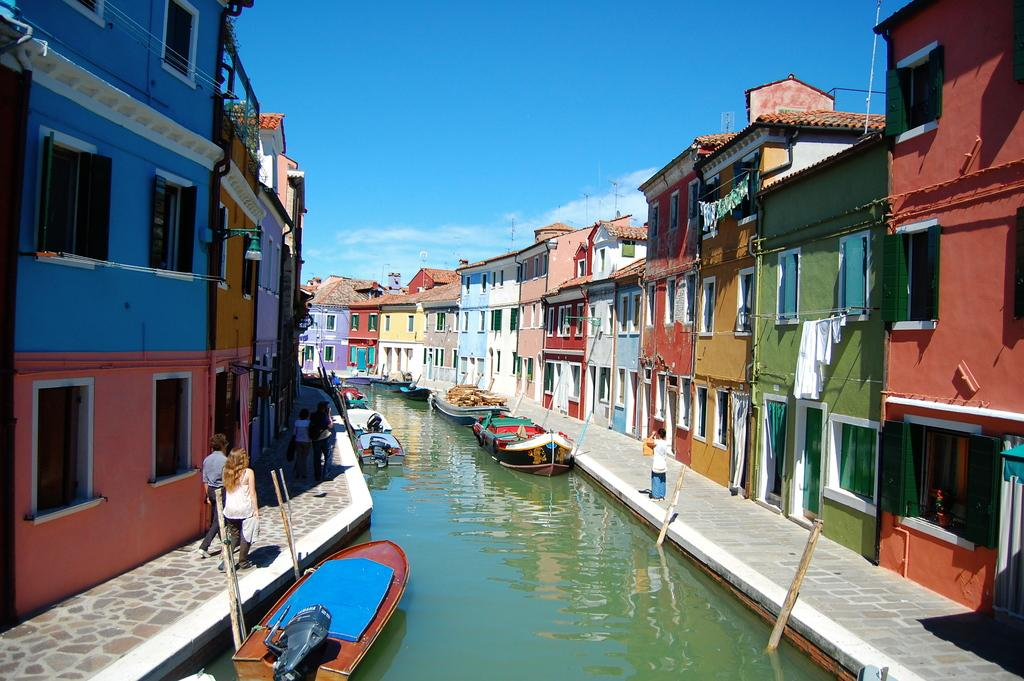What is happening on the water in the image? There are boats on the water in the image. What are the people in the image doing? There are people walking in the image. What can be seen in terms of architecture in the image? There are buildings with multiple colors in the image. What is the color of the sky in the image? The sky is blue in the image. Can you see any shoes on the people walking in the image? There is no information about shoes in the image; we can only see that people are walking. Is there a note left on one of the boats in the image? There is no mention of a note in the image; it only shows boats on the water and people walking. 